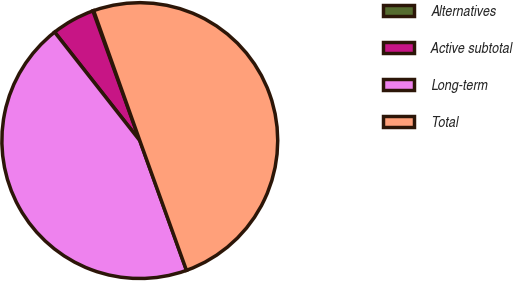Convert chart to OTSL. <chart><loc_0><loc_0><loc_500><loc_500><pie_chart><fcel>Alternatives<fcel>Active subtotal<fcel>Long-term<fcel>Total<nl><fcel>0.09%<fcel>5.07%<fcel>44.9%<fcel>49.93%<nl></chart> 